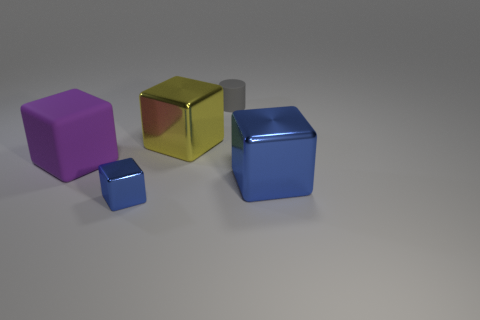Do the big purple rubber object and the big yellow shiny thing have the same shape?
Provide a succinct answer. Yes. There is a large purple rubber thing; are there any small blue objects left of it?
Your response must be concise. No. How many objects are either big yellow metal things or large purple cubes?
Give a very brief answer. 2. How many other objects are there of the same size as the rubber cylinder?
Your answer should be compact. 1. How many things are both behind the small shiny object and in front of the gray matte cylinder?
Ensure brevity in your answer.  3. Do the object that is behind the large yellow thing and the shiny object that is on the right side of the yellow cube have the same size?
Offer a very short reply. No. There is a blue cube that is left of the yellow shiny cube; what size is it?
Make the answer very short. Small. How many things are cubes that are on the left side of the small gray thing or large shiny objects to the left of the tiny gray object?
Offer a very short reply. 3. Are there any other things that are the same color as the small matte thing?
Provide a succinct answer. No. Are there the same number of large purple rubber cubes right of the big yellow cube and large purple blocks that are behind the large purple rubber object?
Provide a succinct answer. Yes. 